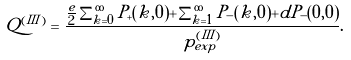<formula> <loc_0><loc_0><loc_500><loc_500>Q ^ { ( I I I ) } = \frac { \frac { e } { 2 } \sum _ { k = 0 } ^ { \infty } P _ { + } ( k , 0 ) + \sum _ { k = 1 } ^ { \infty } P _ { - } ( k , 0 ) + d P _ { - } ( 0 , 0 ) } { p _ { e x p } ^ { ( I I I ) } } .</formula> 